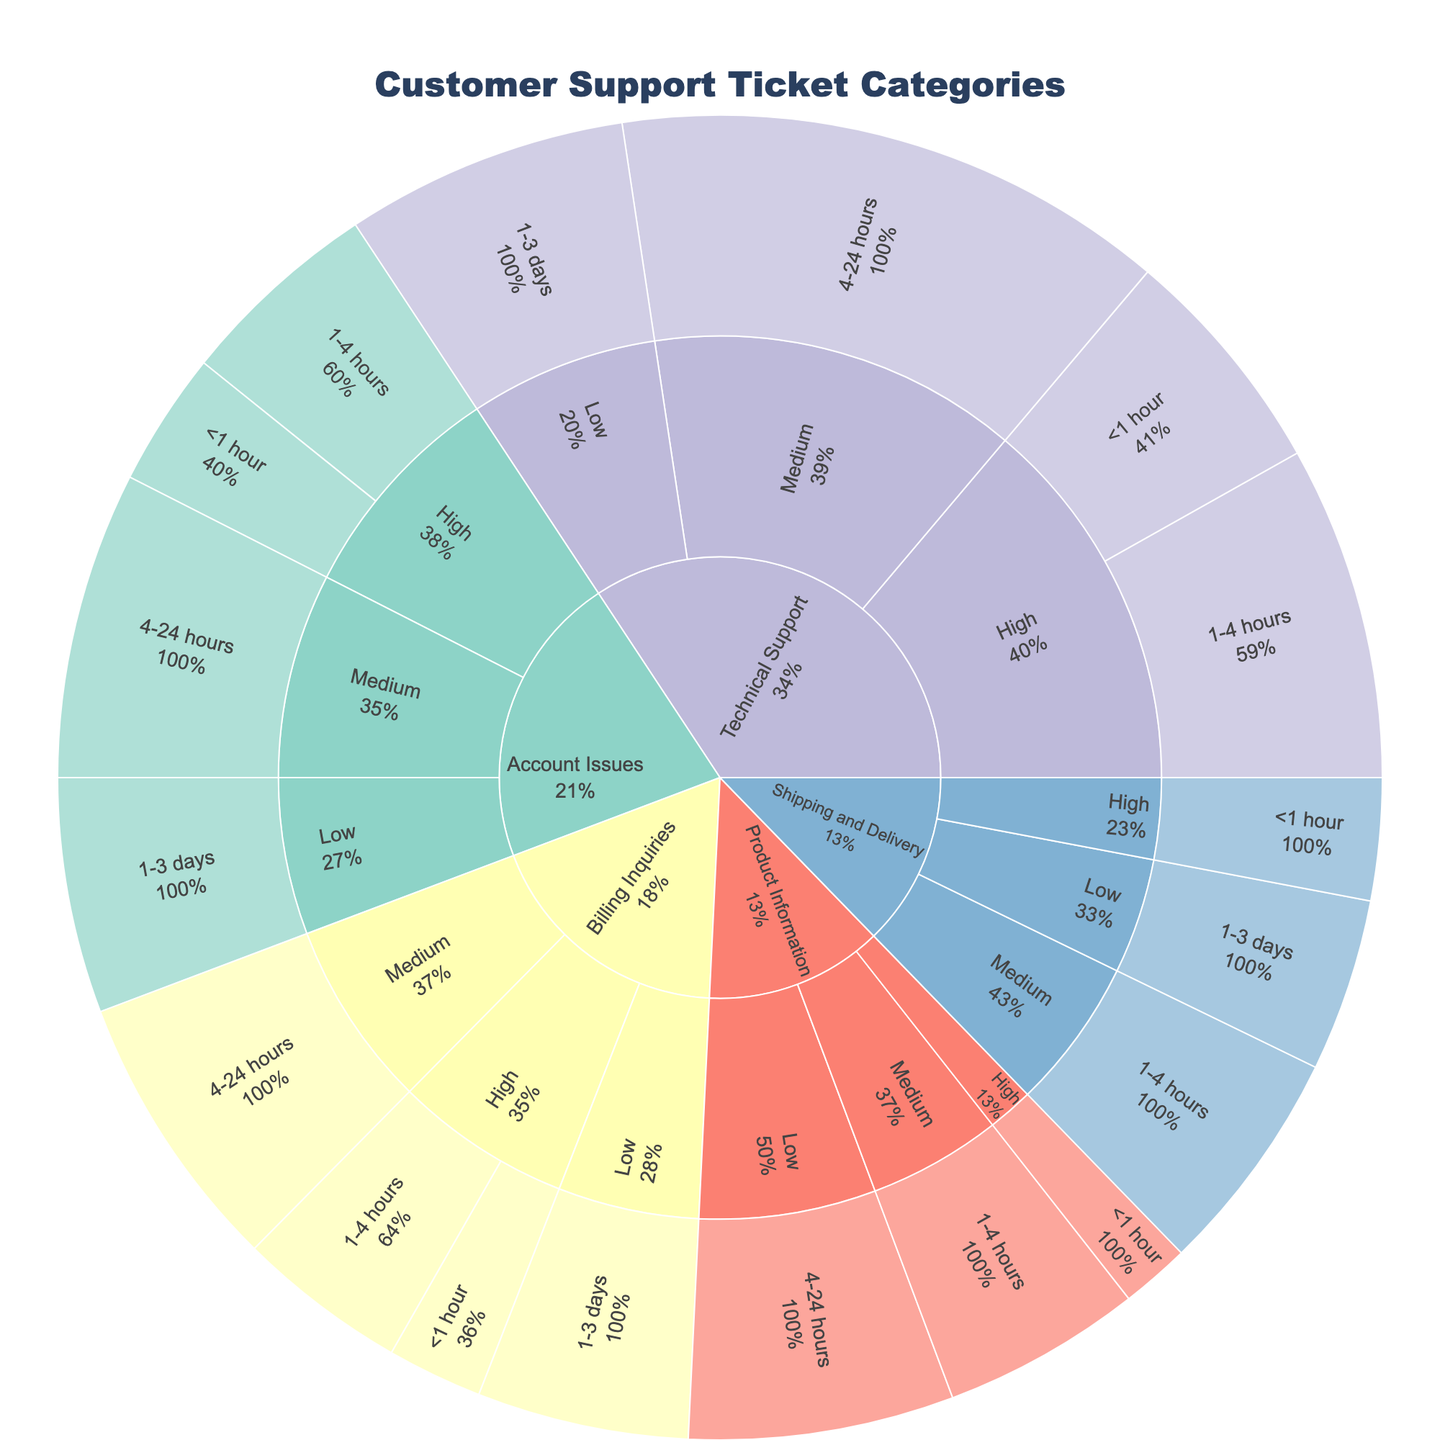What is the title of the plot? The title of the plot is positioned at the top and it reads "Customer Support Ticket Categories"
Answer: Customer Support Ticket Categories How many tickets are categorized under "Technical Support" with high priority? The figure shows counts at each breakdown. For "Technical Support" under high priority, the count is given as 78 (for <1 hour) plus 112 (for 1-4 hours). Summing these gives 78 + 112 = 190
Answer: 190 Which category has the highest percentage of medium priority tickets resolved between 4-24 hours? We need to look for the segment breakdowns for each category with medium priority for the resolution time 4-24 hours. By examining these segments, "Technical Support" shows the highest count for this criteria, thus likely the highest percentage.
Answer: Technical Support What is the total number of "Account Issues" tickets? To find the total, add up the counts for all resolution times and priorities under "Account Issues": 45 (High < 1 hour) + 68 (High 1-4 hours) + 103 (Medium 4-24 hours) + 79 (Low 1-3 days) = 295
Answer: 295 In which category do high-priority tickets take the longest to resolve on average? For estimating average resolution times based on high priority, we compare the proportions of high-priority tickets resolved in <1 hour and 1-4 hours across categories. "Technical Support" has the highest counts in early resolution (78 for <1 hour and 112 for 1-4 hours), likely balancing towards quicker resolutions compared to others. Checking "Billing Inquiries" and others reveals they generally show fewer total counts, so deeper analysis may be required but "Technical Support" stands out.
Answer: Technical Support What is the count of low-priority tickets resolved within 1-3 days for "Shipping and Delivery"? Examine the segment corresponding to "Shipping and Delivery" under low priority and resolved within 1-3 days. The count shown is 58.
Answer: 58 Which category has the most evenly distributed resolution times across all priorities? Evaluate proportions of resolution times under each category. "Account Issues" show a fairly even distribution across priorities and resolution times.
Answer: Account Issues How does the proportion of tickets resolved in less than 1 hour differ between “Billing Inquiries” and “Product Information”? "Billing Inquiries" has 32 (high) tickets resolved in under 1 hour vs. "Product Information" which has 23 (same priority). Compare counts directly.
Answer: 32 vs. 23 What is the proportion of tickets resolved within 4-24 hours in "Technical Support"? For "Technical Support", only consider medium priority for resolution time 4-24 hours with a count of 186. Divide by the total in "Technical Support" (78 + 112 + 186 + 95). Total = 471. Proportion = 186 / 471 = 0.395
Answer: 0.395 